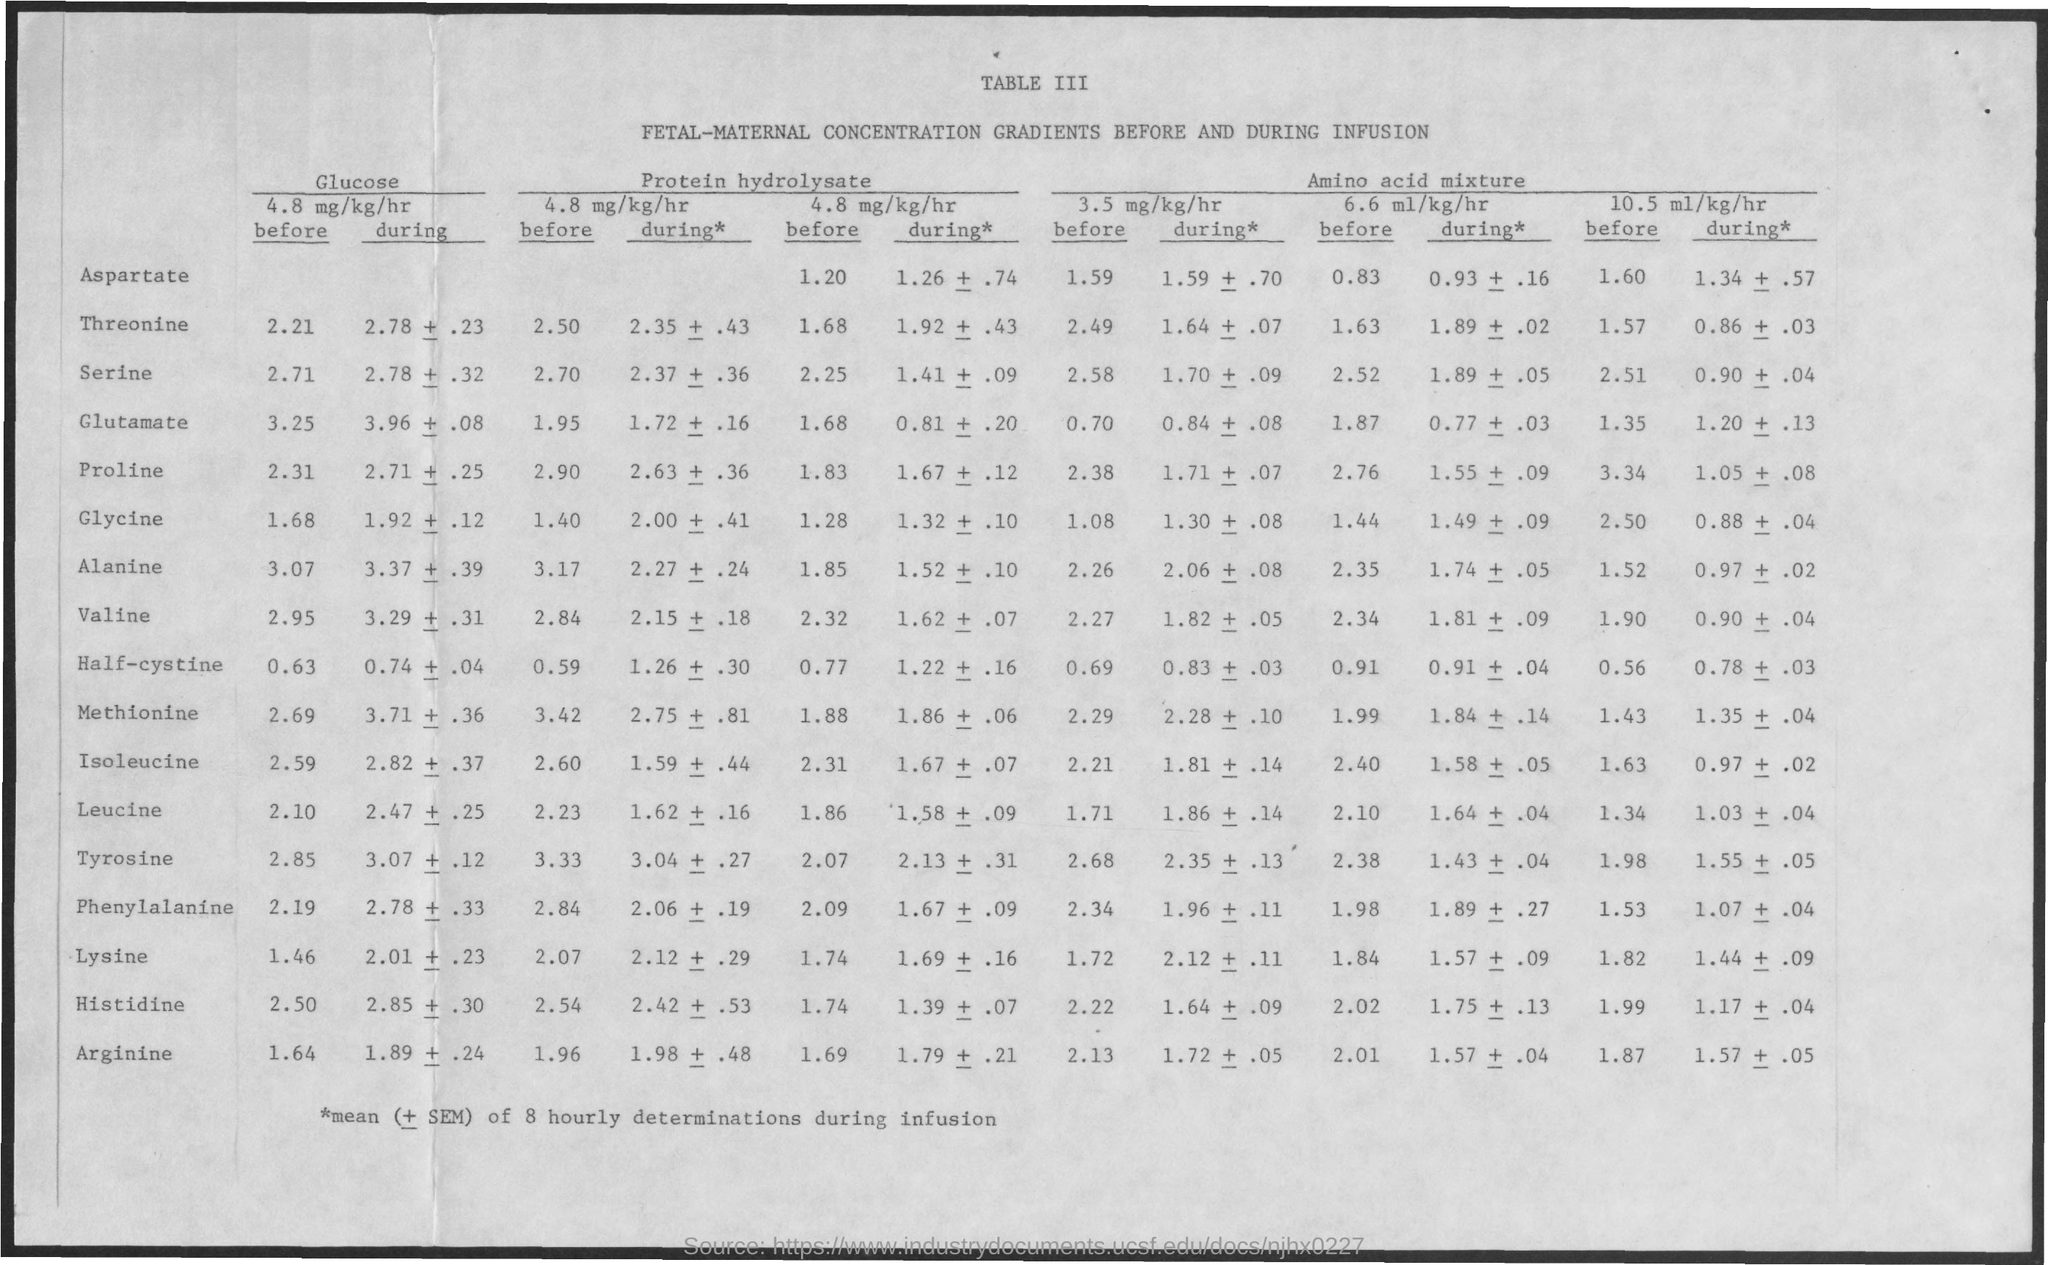Give some essential details in this illustration. The table number is III. TABLE III. 